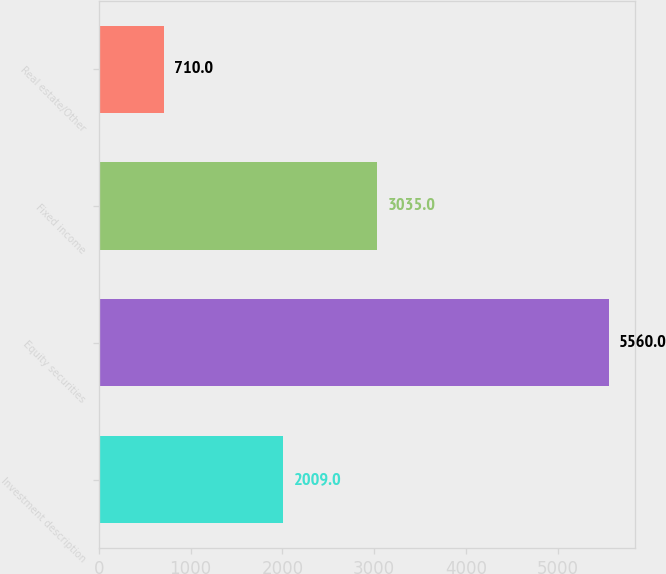Convert chart. <chart><loc_0><loc_0><loc_500><loc_500><bar_chart><fcel>Investment description<fcel>Equity securities<fcel>Fixed income<fcel>Real estate/Other<nl><fcel>2009<fcel>5560<fcel>3035<fcel>710<nl></chart> 